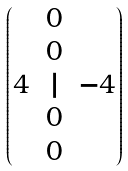Convert formula to latex. <formula><loc_0><loc_0><loc_500><loc_500>\begin{pmatrix} & 0 & \\ & 0 & \\ 4 & | & - 4 \\ & 0 & \\ & 0 & \end{pmatrix}</formula> 